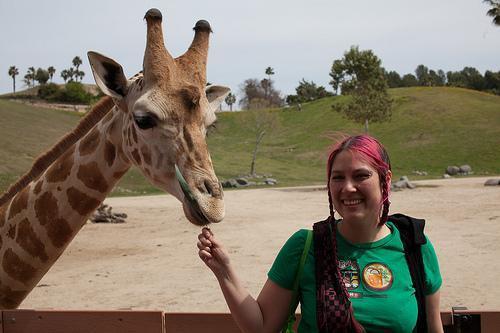How many giraffes are shown?
Give a very brief answer. 1. 